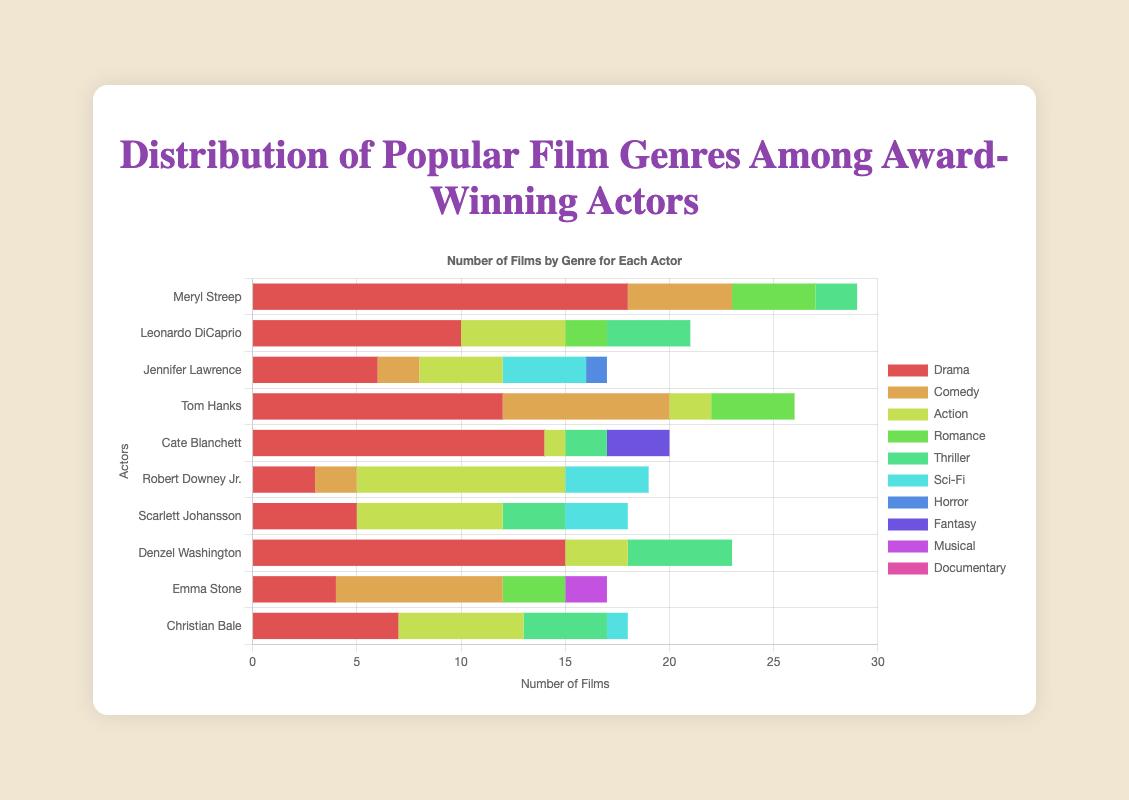Which actor has the highest number of Drama films? Meryl Streep has the highest number of Drama films, which can be seen by looking at the Drama bar for each actor. Meryl Streep's Drama bar is the longest at 18 films.
Answer: Meryl Streep How many Sci-Fi films has Scarlett Johansson acted in? Look at the bar labeled "Sci-Fi" for Scarlett Johansson. The value indicated here is 3.
Answer: 3 Who has acted in more comedy films, Tom Hanks or Emma Stone? Compare the lengths of the Comedy bars for Tom Hanks and Emma Stone. Tom Hanks has a longer Comedy bar with 8 films, while Emma Stone has 8 as well. Both are equal.
Answer: Both are equal What is the total number of Action films by Leonardo DiCaprio and Christian Bale? Add the number of Action films by Leonardo DiCaprio (5) and Christian Bale (6). 5 + 6 = 11.
Answer: 11 Which actor has the least number of genres participated in and what are they? To find the actor with the least number of genres, look at the number of bars for each actor. Cate Blanchett has bars for the fewest genres: Drama, Fantasy, Thriller, and Action.
Answer: Cate Blanchett; Drama, Fantasy, Thriller, Action By how much does Denzel Washington's number of Thriller films exceed that of Robert Downey Jr.? Look at the Thriller bars for Denzel Washington (5) and Robert Downey Jr. (0). Subtract 0 from 5 to get 5.
Answer: 5 How many total films has Jennifer Lawrence acted in across all listed genres? Sum up the values of all bars for Jennifer Lawrence: 4 (Sci-Fi) + 4 (Action) + 6 (Drama) + 2 (Comedy) + 1 (Horror) = 17.
Answer: 17 Who has more total films, Robert Downey Jr. or Christian Bale? Sum up the values of all bars for Robert Downey Jr.: 10 (Action) + 4 (Sci-Fi) + 3 (Drama) + 2 (Comedy) = 19. Do the same for Christian Bale: 7 (Drama) + 6 (Action) + 4 (Thriller) + 1 (Sci-Fi) = 18. Robert Downey Jr. has more films.
Answer: Robert Downey Jr Which genres has Meryl Streep never participated in according to the chart? Identify the genres without bars for Meryl Streep: Action, Sci-Fi, Horror, Fantasy, Musical, Documentary.
Answer: Action, Sci-Fi, Horror, Fantasy, Musical, Documentary Who has the most balanced distribution of films across genres and why? To find the actor with the most balanced distribution, look for the actor whose bars are closest in length across multiple genres. Tom Hanks has relatively even lengths across Drama (12), Comedy (8), Romance (4), and Action (2), indicating a balanced distribution.
Answer: Tom Hanks 